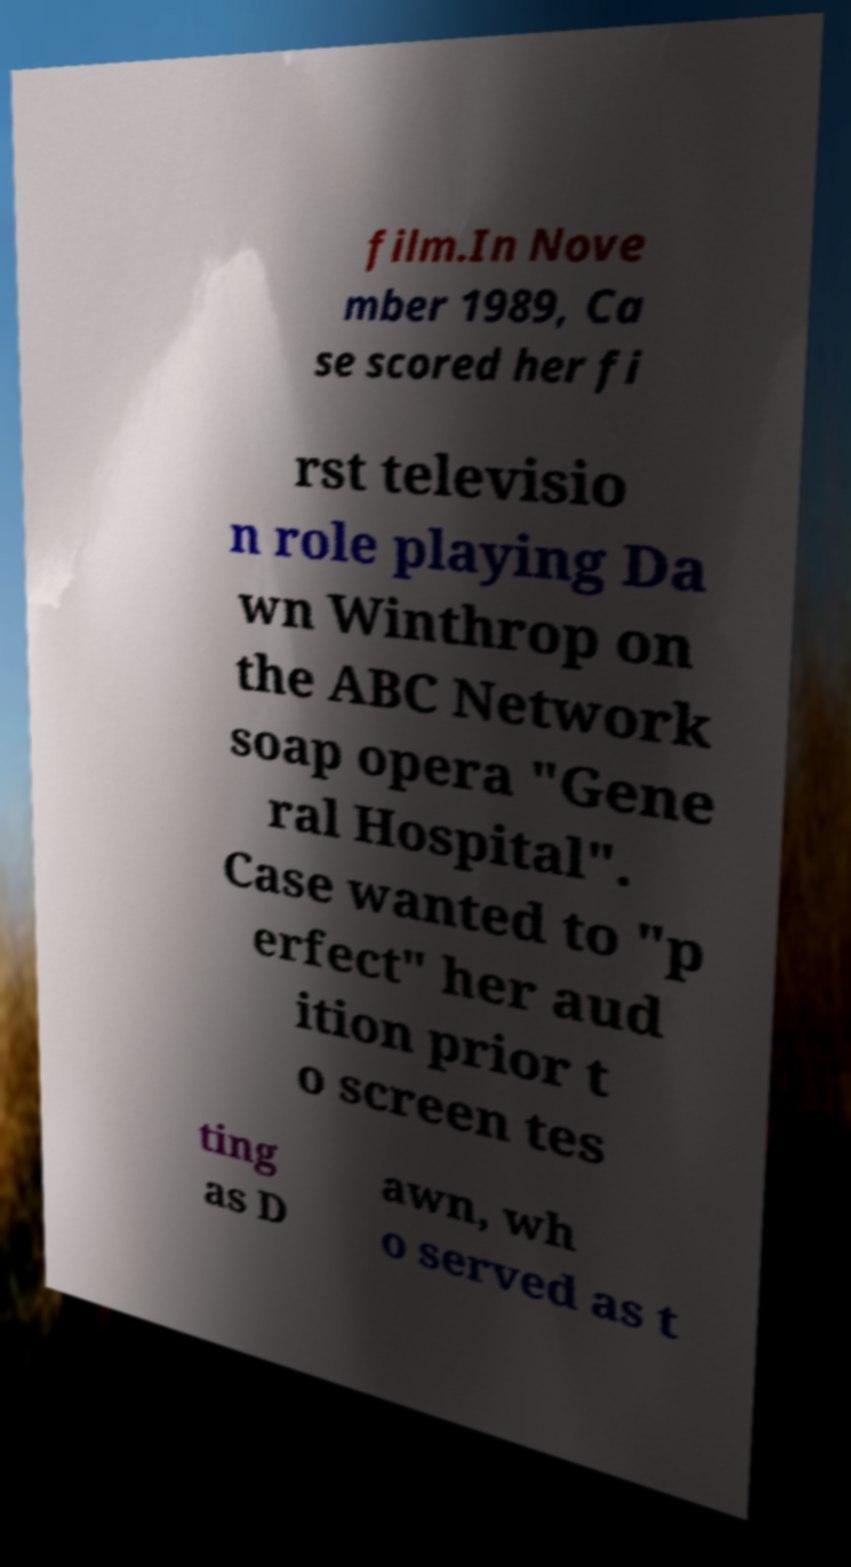Can you accurately transcribe the text from the provided image for me? film.In Nove mber 1989, Ca se scored her fi rst televisio n role playing Da wn Winthrop on the ABC Network soap opera "Gene ral Hospital". Case wanted to "p erfect" her aud ition prior t o screen tes ting as D awn, wh o served as t 